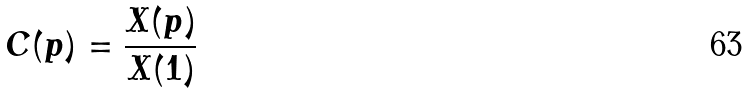<formula> <loc_0><loc_0><loc_500><loc_500>C ( p ) = \frac { X ( p ) } { X ( 1 ) }</formula> 